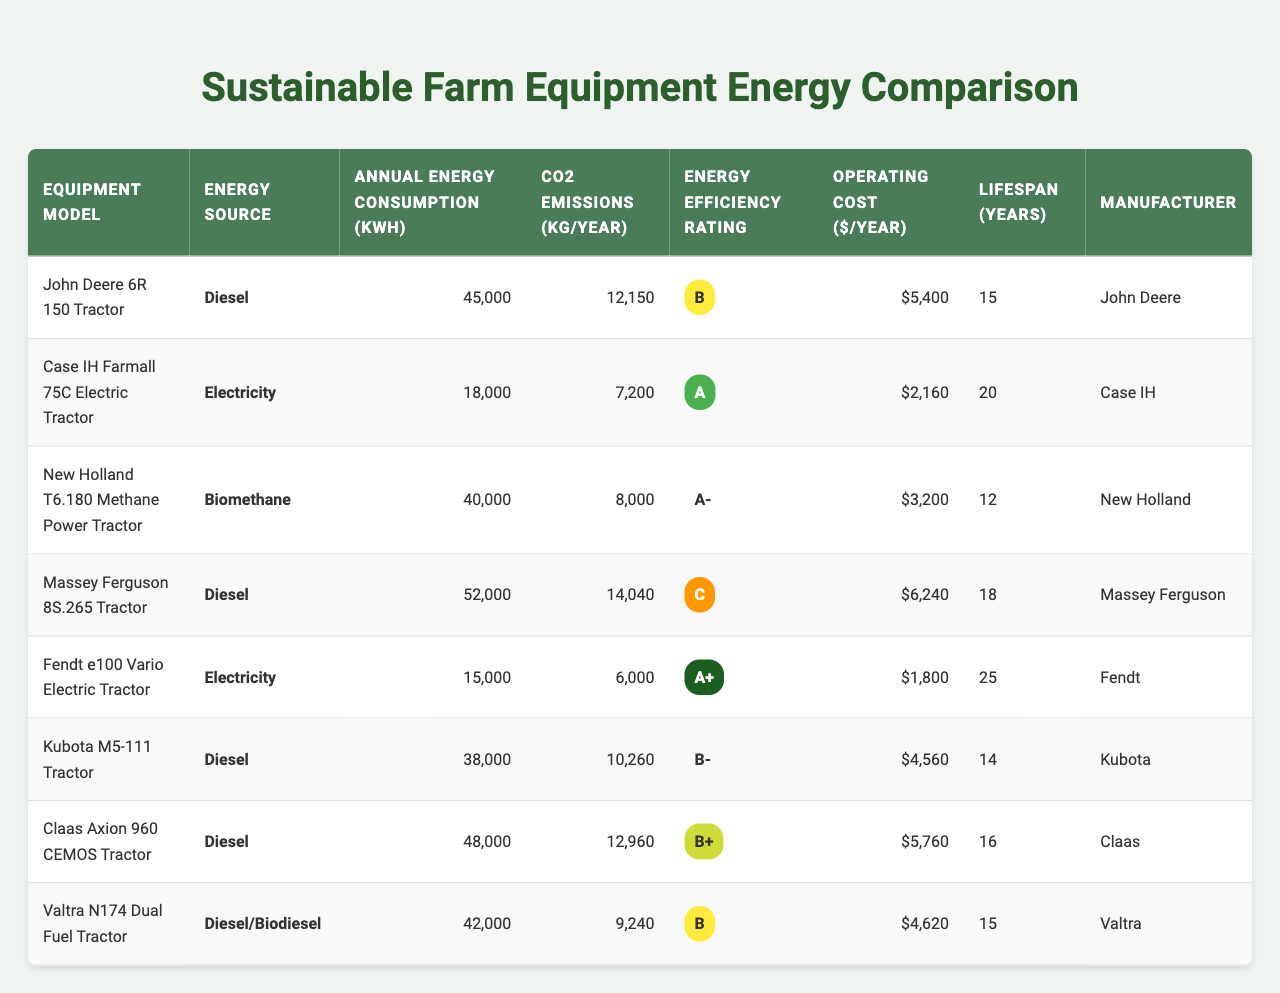What is the energy source for the Fendt e100 Vario Electric Tractor? The table lists the Fendt e100 Vario Electric Tractor's energy source in the corresponding row, which is labeled "Electricity."
Answer: Electricity Which tractor has the highest annual energy consumption? Looking at the "Annual Energy Consumption" column, the Massey Ferguson 8S.265 Tractor has the highest value at 52,000 kWh.
Answer: Massey Ferguson 8S.265 Tractor What are the CO2 emissions for the Case IH Farmall 75C Electric Tractor? The "CO2 Emissions" column shows that the Case IH Farmall 75C Electric Tractor emits 7,200 kg/year.
Answer: 7,200 kg/year Is the New Holland T6.180 Methane Power Tractor more energy-efficient than the John Deere 6R 150 Tractor? The energy efficiency rating for New Holland T6.180 is A- and for John Deere 6R 150 is B, indicating that A- is better than B.
Answer: Yes What is the average lifespan of the tractors listed in the table? The lifespans are 15, 20, 12, 18, 25, 14, 16, and 15 years. Summing these gives 120 years, and dividing by 8 yields an average lifespan of 15 years.
Answer: 15 years How much does the Kubota M5-111 Tractor cost to operate annually? The "Operating Cost" column shows that the Kubota M5-111 Tractor has an operating cost of $4,560 per year.
Answer: $4,560 Which manufacturer offers the most energy-efficient tractor model based on the ratings provided? The table shows that Fendt's e100 Vario has the highest efficiency rating of A+. Therefore, Fendt offers the most energy-efficient model.
Answer: Fendt What is the total CO2 emissions from the two electric tractor models combined? The CO2 emissions for the Case IH Farmall 75C Electric Tractor is 7,200 kg/year and for the Fendt e100 Vario, it is 6,000 kg/year. Adding these gives 7,200 + 6,000 = 13,200 kg/year combined.
Answer: 13,200 kg/year How does the energy efficiency rating of the Valtra N174 Dual Fuel Tractor compare to that of the Massey Ferguson 8S.265 Tractor? The Valtra N174 has a rating of B, while the Massey Ferguson 8S.265 has a rating of C, which suggests that the Valtra N174 is more energy efficient.
Answer: Valtra N174 is more efficient What is the difference in annual energy consumption between the John Deere 6R 150 Tractor and the New Holland T6.180 Methane Power Tractor? The John Deere 6R 150 consumes 45,000 kWh/year and the New Holland T6.180 consumes 40,000 kWh/year. The difference is 45,000 - 40,000 = 5,000 kWh/year.
Answer: 5,000 kWh/year 